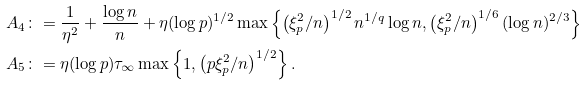Convert formula to latex. <formula><loc_0><loc_0><loc_500><loc_500>A _ { 4 } & \colon = \frac { 1 } { \eta ^ { 2 } } + \frac { \log n } { n } + \eta ( \log p ) ^ { 1 / 2 } \max \left \{ \left ( \xi _ { p } ^ { 2 } / n \right ) ^ { 1 / 2 } n ^ { 1 / q } \log n , \left ( \xi _ { p } ^ { 2 } / n \right ) ^ { 1 / 6 } ( \log n ) ^ { 2 / 3 } \right \} \\ A _ { 5 } & \colon = \eta ( \log p ) \tau _ { \infty } \max \left \{ 1 , \left ( p \xi _ { p } ^ { 2 } / n \right ) ^ { 1 / 2 } \right \} .</formula> 